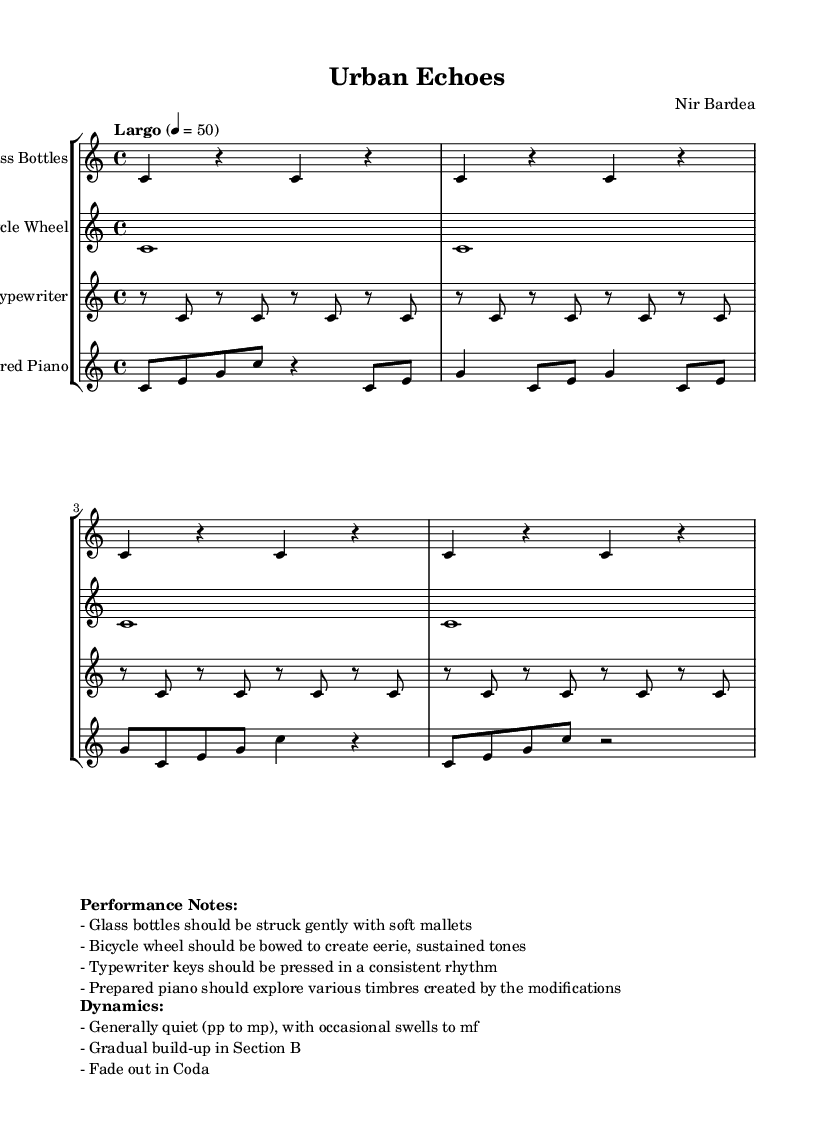What is the key signature of this music? The key signature is displayed at the beginning of the score, indicating that it is in C major, which has no sharps or flats.
Answer: C major What is the time signature of this music? The time signature appears next to the key signature at the beginning of the score, showing that it is 4/4, meaning there are four beats in each measure.
Answer: 4/4 What is the tempo indication for this piece? The tempo is indicated on the score with the term "Largo" and a metronome marking of 50, meaning it should be played slowly at that pace.
Answer: Largo, 50 Which instrument plays the longest note value in the score? By examining the measures, the bicycle wheel is assigned whole notes (c1) throughout the entire section, which is the longest note value in the piece.
Answer: Bicycle Wheel What dynamics are primarily used in this composition? The performance notes specify that the dynamics range from quiet (pp) to moderately loud (mf), indicating a gentle sound overall with some moments of louder swells.
Answer: pp to mf How should the glass bottles be struck according to the performance notes? The performance notes describe that glass bottles should be struck gently with soft mallets, outlining the intended playing technique for this unconventional instrument.
Answer: Gently with soft mallets What role does the prepared piano play in this composition? The prepared piano notes reveal various modified timbres being explored, emphasizing the instrument’s versatility and experimentation within the minimalist context of the piece.
Answer: Explore various timbres 